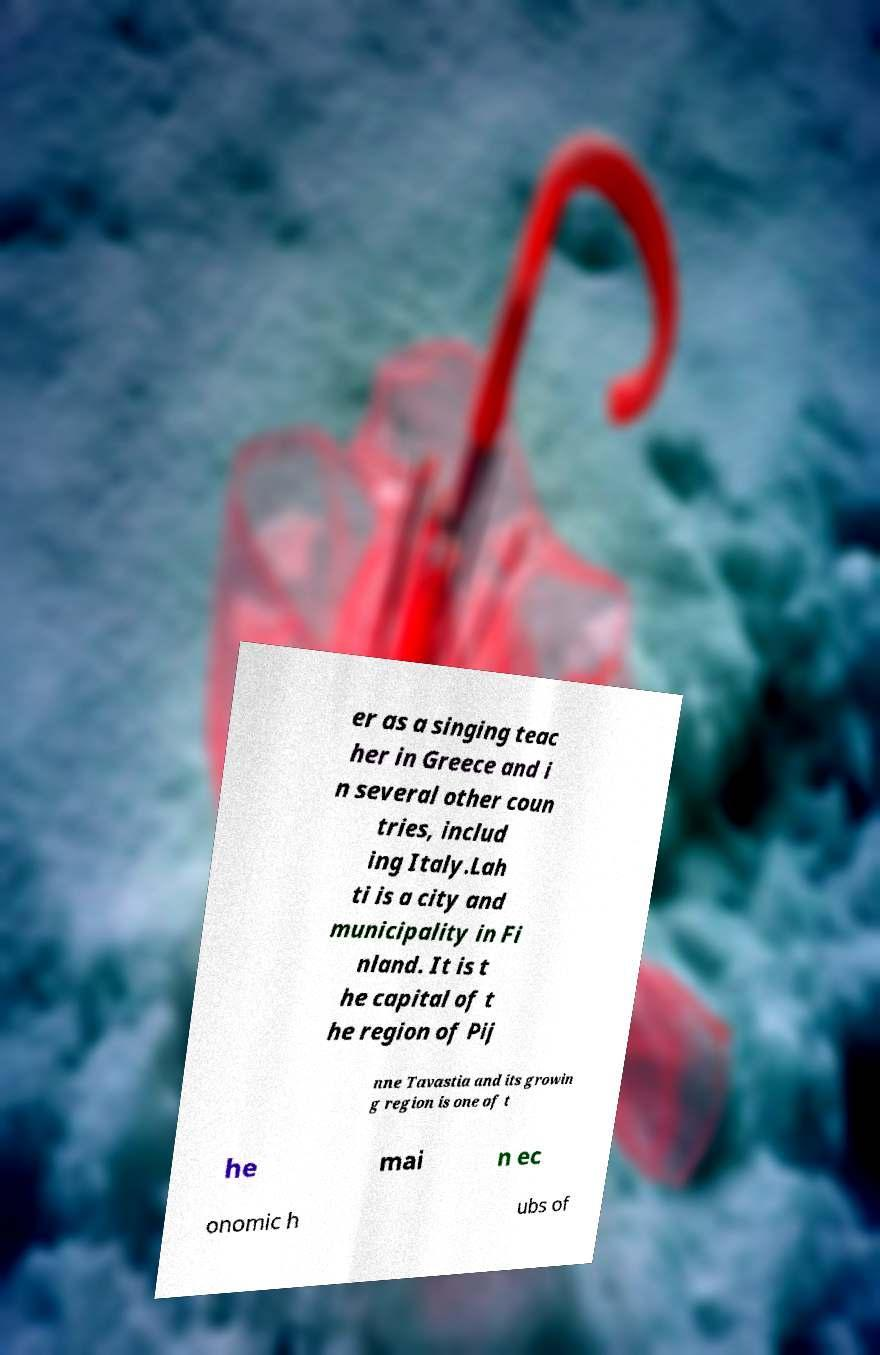There's text embedded in this image that I need extracted. Can you transcribe it verbatim? er as a singing teac her in Greece and i n several other coun tries, includ ing Italy.Lah ti is a city and municipality in Fi nland. It is t he capital of t he region of Pij nne Tavastia and its growin g region is one of t he mai n ec onomic h ubs of 